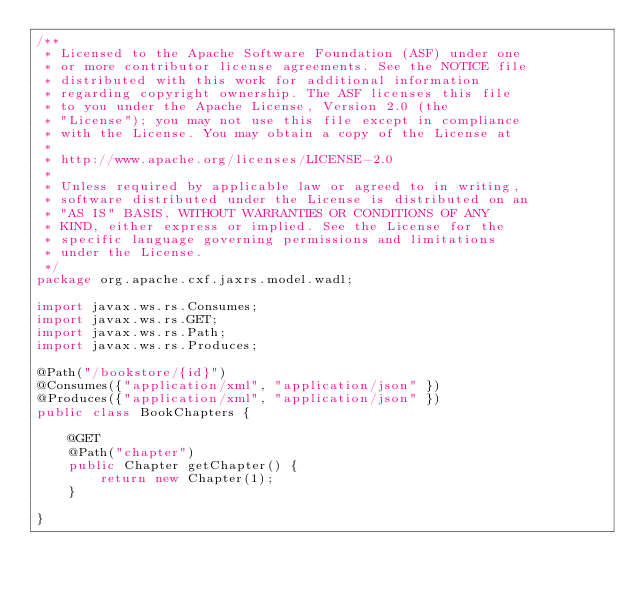<code> <loc_0><loc_0><loc_500><loc_500><_Java_>/**
 * Licensed to the Apache Software Foundation (ASF) under one
 * or more contributor license agreements. See the NOTICE file
 * distributed with this work for additional information
 * regarding copyright ownership. The ASF licenses this file
 * to you under the Apache License, Version 2.0 (the
 * "License"); you may not use this file except in compliance
 * with the License. You may obtain a copy of the License at
 *
 * http://www.apache.org/licenses/LICENSE-2.0
 *
 * Unless required by applicable law or agreed to in writing,
 * software distributed under the License is distributed on an
 * "AS IS" BASIS, WITHOUT WARRANTIES OR CONDITIONS OF ANY
 * KIND, either express or implied. See the License for the
 * specific language governing permissions and limitations
 * under the License.
 */
package org.apache.cxf.jaxrs.model.wadl;

import javax.ws.rs.Consumes;
import javax.ws.rs.GET;
import javax.ws.rs.Path;
import javax.ws.rs.Produces;

@Path("/bookstore/{id}")
@Consumes({"application/xml", "application/json" })
@Produces({"application/xml", "application/json" })
public class BookChapters {

    @GET
    @Path("chapter")
    public Chapter getChapter() {
        return new Chapter(1);
    }

}
</code> 